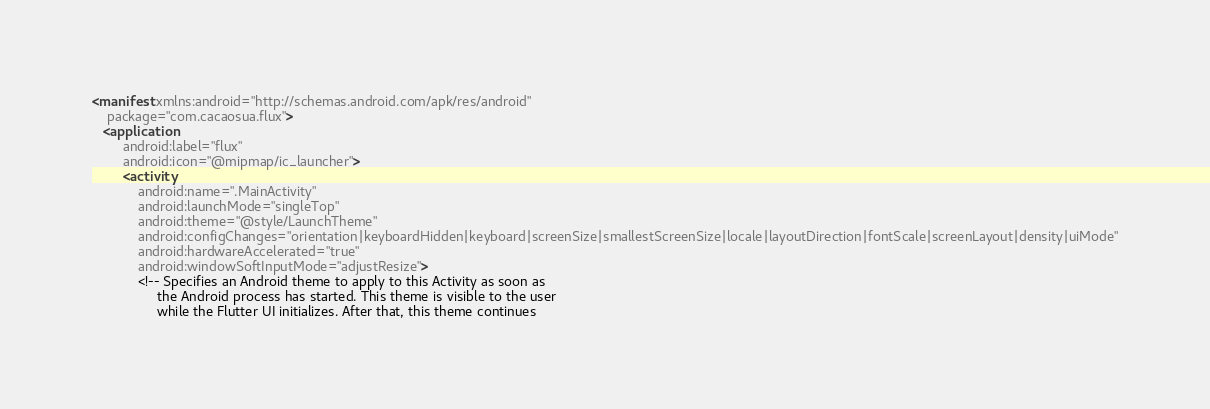Convert code to text. <code><loc_0><loc_0><loc_500><loc_500><_XML_><manifest xmlns:android="http://schemas.android.com/apk/res/android"
    package="com.cacaosua.flux">
   <application
        android:label="flux"
        android:icon="@mipmap/ic_launcher">
        <activity
            android:name=".MainActivity"
            android:launchMode="singleTop"
            android:theme="@style/LaunchTheme"
            android:configChanges="orientation|keyboardHidden|keyboard|screenSize|smallestScreenSize|locale|layoutDirection|fontScale|screenLayout|density|uiMode"
            android:hardwareAccelerated="true"
            android:windowSoftInputMode="adjustResize">
            <!-- Specifies an Android theme to apply to this Activity as soon as
                 the Android process has started. This theme is visible to the user
                 while the Flutter UI initializes. After that, this theme continues</code> 